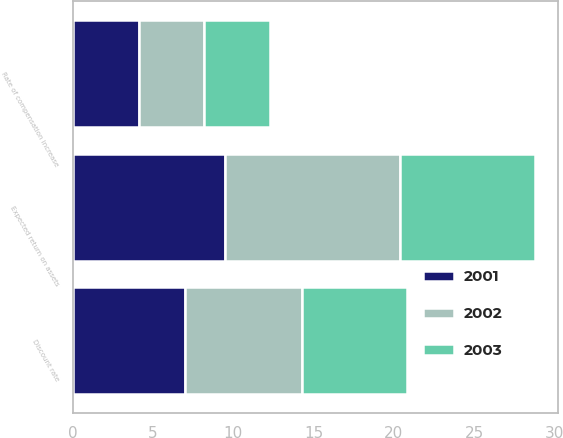<chart> <loc_0><loc_0><loc_500><loc_500><stacked_bar_chart><ecel><fcel>Discount rate<fcel>Expected return on assets<fcel>Rate of compensation increase<nl><fcel>2003<fcel>6.5<fcel>8.4<fcel>4.1<nl><fcel>2001<fcel>7<fcel>9.5<fcel>4.1<nl><fcel>2002<fcel>7.3<fcel>10.9<fcel>4.1<nl></chart> 